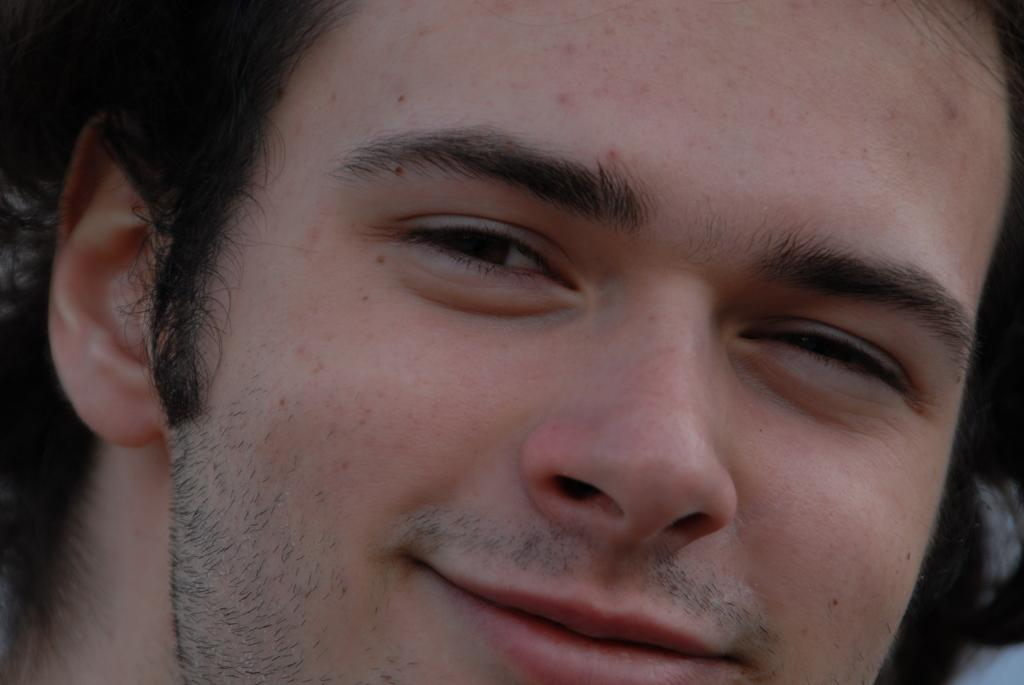What is the main subject of the image? There is a man in the image. What is the man's facial expression in the image? The man is smiling in the image. Which facial features of the man are visible in the image? The image shows the man's ear, eyes, nose, and mouth. What type of mint can be seen growing near the man in the image? There is no mint present in the image, and the man is not shown near any plants. 